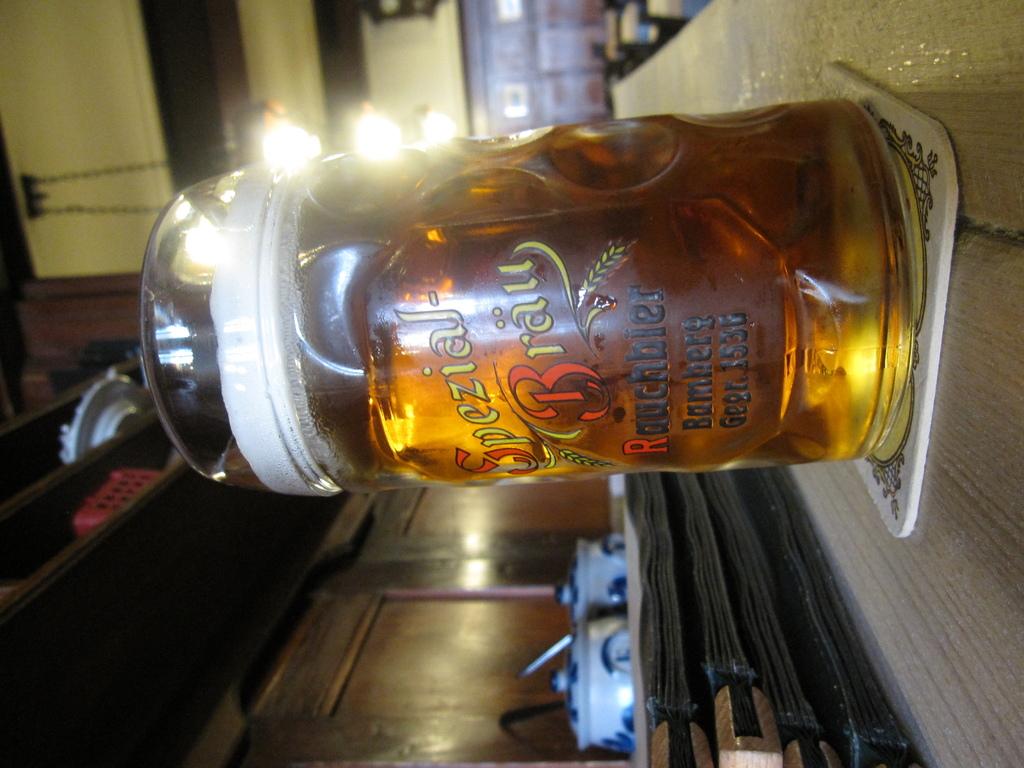Is the text on the mug in english?
Offer a terse response. No. What is the numerical number written in the bottom of the bottle?
Offer a very short reply. 1536. 